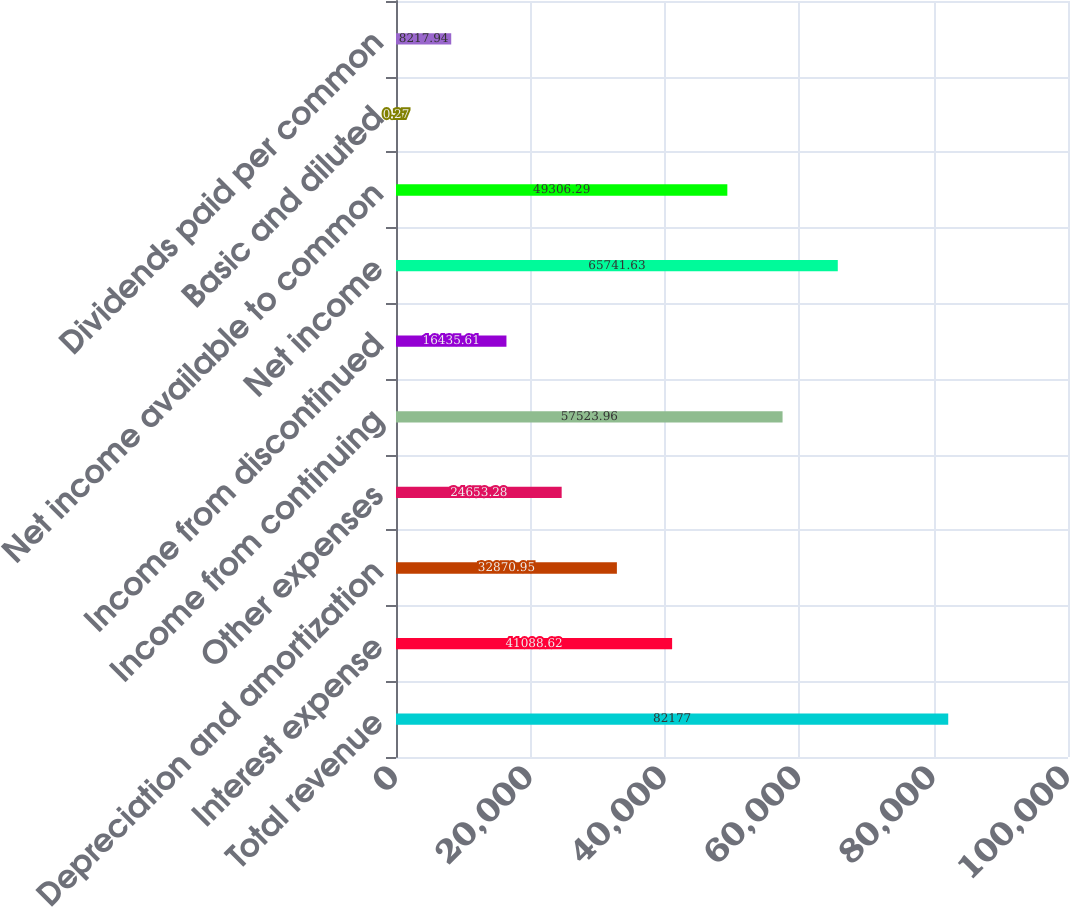Convert chart. <chart><loc_0><loc_0><loc_500><loc_500><bar_chart><fcel>Total revenue<fcel>Interest expense<fcel>Depreciation and amortization<fcel>Other expenses<fcel>Income from continuing<fcel>Income from discontinued<fcel>Net income<fcel>Net income available to common<fcel>Basic and diluted<fcel>Dividends paid per common<nl><fcel>82177<fcel>41088.6<fcel>32870.9<fcel>24653.3<fcel>57524<fcel>16435.6<fcel>65741.6<fcel>49306.3<fcel>0.27<fcel>8217.94<nl></chart> 